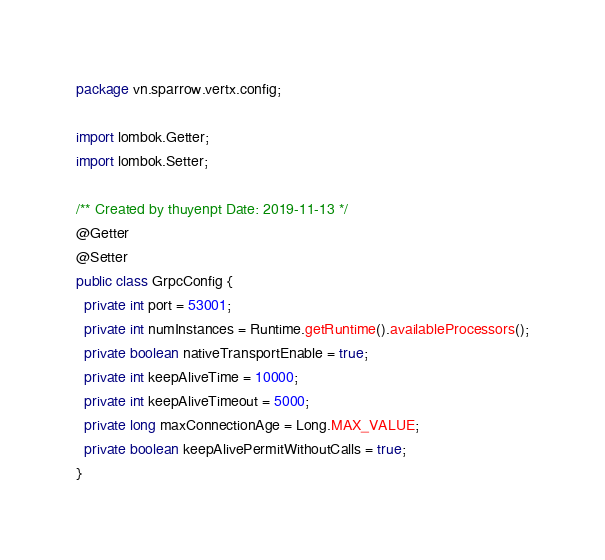Convert code to text. <code><loc_0><loc_0><loc_500><loc_500><_Java_>package vn.sparrow.vertx.config;

import lombok.Getter;
import lombok.Setter;

/** Created by thuyenpt Date: 2019-11-13 */
@Getter
@Setter
public class GrpcConfig {
  private int port = 53001;
  private int numInstances = Runtime.getRuntime().availableProcessors();
  private boolean nativeTransportEnable = true;
  private int keepAliveTime = 10000;
  private int keepAliveTimeout = 5000;
  private long maxConnectionAge = Long.MAX_VALUE;
  private boolean keepAlivePermitWithoutCalls = true;
}
</code> 